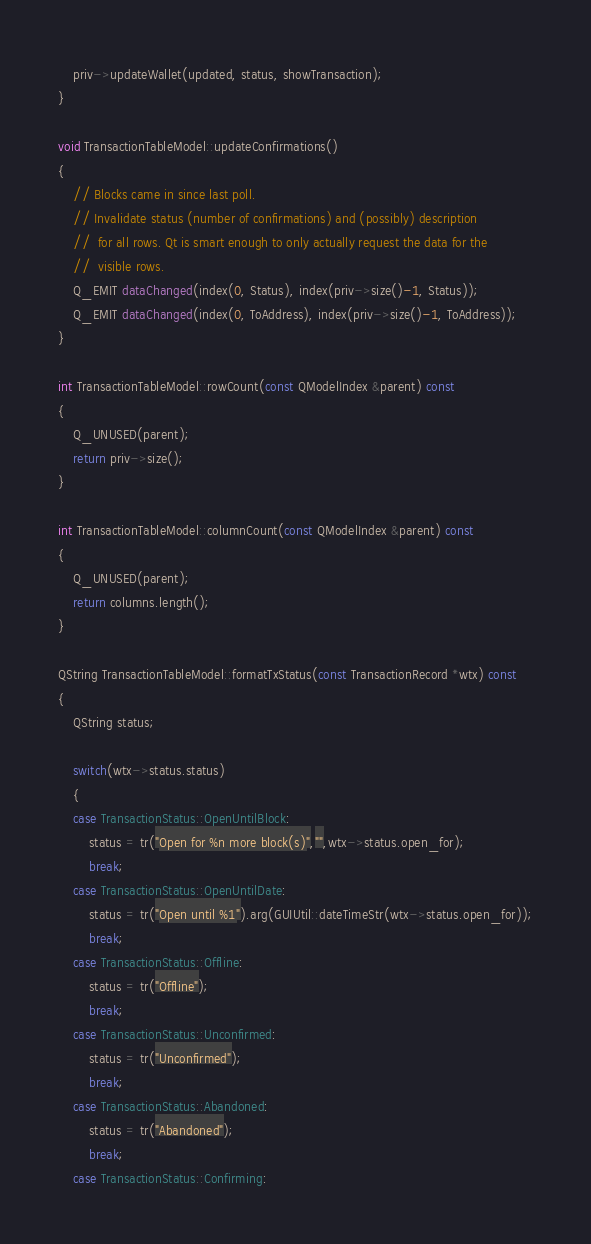Convert code to text. <code><loc_0><loc_0><loc_500><loc_500><_C++_>
    priv->updateWallet(updated, status, showTransaction);
}

void TransactionTableModel::updateConfirmations()
{
    // Blocks came in since last poll.
    // Invalidate status (number of confirmations) and (possibly) description
    //  for all rows. Qt is smart enough to only actually request the data for the
    //  visible rows.
    Q_EMIT dataChanged(index(0, Status), index(priv->size()-1, Status));
    Q_EMIT dataChanged(index(0, ToAddress), index(priv->size()-1, ToAddress));
}

int TransactionTableModel::rowCount(const QModelIndex &parent) const
{
    Q_UNUSED(parent);
    return priv->size();
}

int TransactionTableModel::columnCount(const QModelIndex &parent) const
{
    Q_UNUSED(parent);
    return columns.length();
}

QString TransactionTableModel::formatTxStatus(const TransactionRecord *wtx) const
{
    QString status;

    switch(wtx->status.status)
    {
    case TransactionStatus::OpenUntilBlock:
        status = tr("Open for %n more block(s)","",wtx->status.open_for);
        break;
    case TransactionStatus::OpenUntilDate:
        status = tr("Open until %1").arg(GUIUtil::dateTimeStr(wtx->status.open_for));
        break;
    case TransactionStatus::Offline:
        status = tr("Offline");
        break;
    case TransactionStatus::Unconfirmed:
        status = tr("Unconfirmed");
        break;
    case TransactionStatus::Abandoned:
        status = tr("Abandoned");
        break;
    case TransactionStatus::Confirming:</code> 